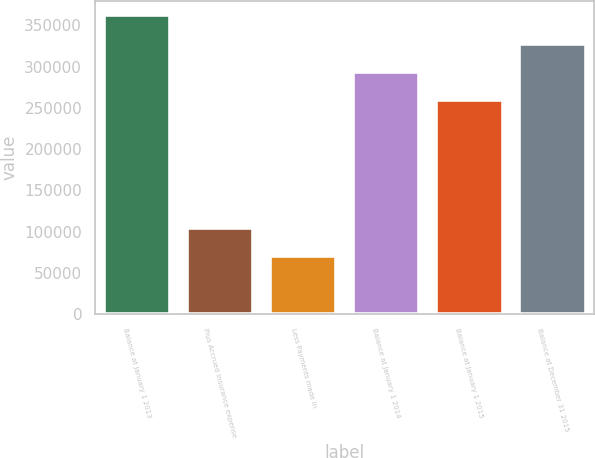<chart> <loc_0><loc_0><loc_500><loc_500><bar_chart><fcel>Balance at January 1 2013<fcel>Plus Accrued insurance expense<fcel>Less Payments made in<fcel>Balance at January 1 2014<fcel>Balance at January 1 2015<fcel>Balance at December 31 2015<nl><fcel>361938<fcel>104717<fcel>70644<fcel>293791<fcel>259718<fcel>327864<nl></chart> 